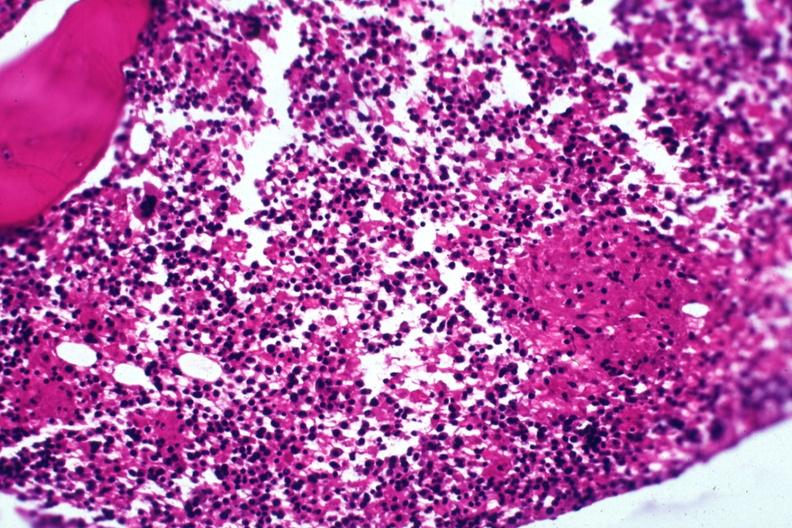s malignant lymphoma present?
Answer the question using a single word or phrase. No 